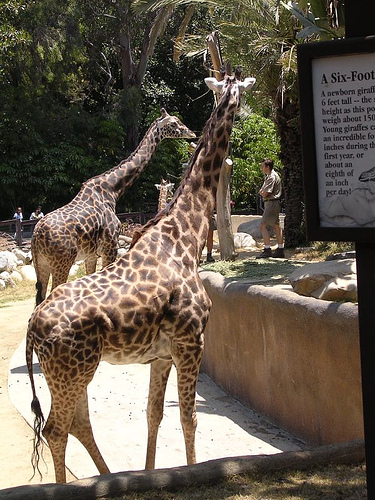Identify the text contained in this image. A Six -Foot feet Inches inch eighth nn about of first during incredible giraffes Young about 15 the G girail newborn 